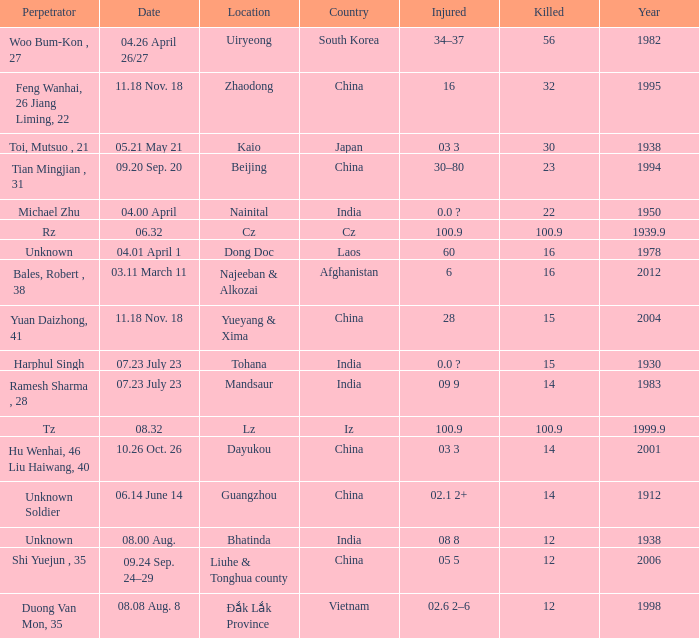Could you parse the entire table as a dict? {'header': ['Perpetrator', 'Date', 'Location', 'Country', 'Injured', 'Killed', 'Year'], 'rows': [['Woo Bum-Kon , 27', '04.26 April 26/27', 'Uiryeong', 'South Korea', '34–37', '56', '1982'], ['Feng Wanhai, 26 Jiang Liming, 22', '11.18 Nov. 18', 'Zhaodong', 'China', '16', '32', '1995'], ['Toi, Mutsuo , 21', '05.21 May 21', 'Kaio', 'Japan', '03 3', '30', '1938'], ['Tian Mingjian , 31', '09.20 Sep. 20', 'Beijing', 'China', '30–80', '23', '1994'], ['Michael Zhu', '04.00 April', 'Nainital', 'India', '0.0 ?', '22', '1950'], ['Rz', '06.32', 'Cz', 'Cz', '100.9', '100.9', '1939.9'], ['Unknown', '04.01 April 1', 'Dong Doc', 'Laos', '60', '16', '1978'], ['Bales, Robert , 38', '03.11 March 11', 'Najeeban & Alkozai', 'Afghanistan', '6', '16', '2012'], ['Yuan Daizhong, 41', '11.18 Nov. 18', 'Yueyang & Xima', 'China', '28', '15', '2004'], ['Harphul Singh', '07.23 July 23', 'Tohana', 'India', '0.0 ?', '15', '1930'], ['Ramesh Sharma , 28', '07.23 July 23', 'Mandsaur', 'India', '09 9', '14', '1983'], ['Tz', '08.32', 'Lz', 'Iz', '100.9', '100.9', '1999.9'], ['Hu Wenhai, 46 Liu Haiwang, 40', '10.26 Oct. 26', 'Dayukou', 'China', '03 3', '14', '2001'], ['Unknown Soldier', '06.14 June 14', 'Guangzhou', 'China', '02.1 2+', '14', '1912'], ['Unknown', '08.00 Aug.', 'Bhatinda', 'India', '08 8', '12', '1938'], ['Shi Yuejun , 35', '09.24 Sep. 24–29', 'Liuhe & Tonghua county', 'China', '05 5', '12', '2006'], ['Duong Van Mon, 35', '08.08 Aug. 8', 'Đắk Lắk Province', 'Vietnam', '02.6 2–6', '12', '1998']]} What is Country, when Killed is "100.9", and when Year is greater than 1939.9? Iz. 